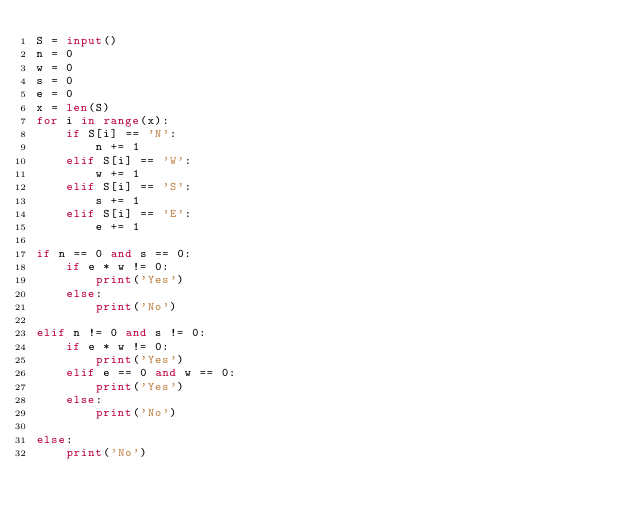<code> <loc_0><loc_0><loc_500><loc_500><_Python_>S = input()
n = 0
w = 0
s = 0
e = 0
x = len(S)
for i in range(x):
    if S[i] == 'N':
        n += 1
    elif S[i] == 'W':
        w += 1
    elif S[i] == 'S':
        s += 1
    elif S[i] == 'E':
        e += 1

if n == 0 and s == 0:
    if e * w != 0:
        print('Yes')
    else:
        print('No')

elif n != 0 and s != 0:
    if e * w != 0:
        print('Yes')
    elif e == 0 and w == 0:
        print('Yes')
    else:
        print('No')

else:
    print('No')</code> 